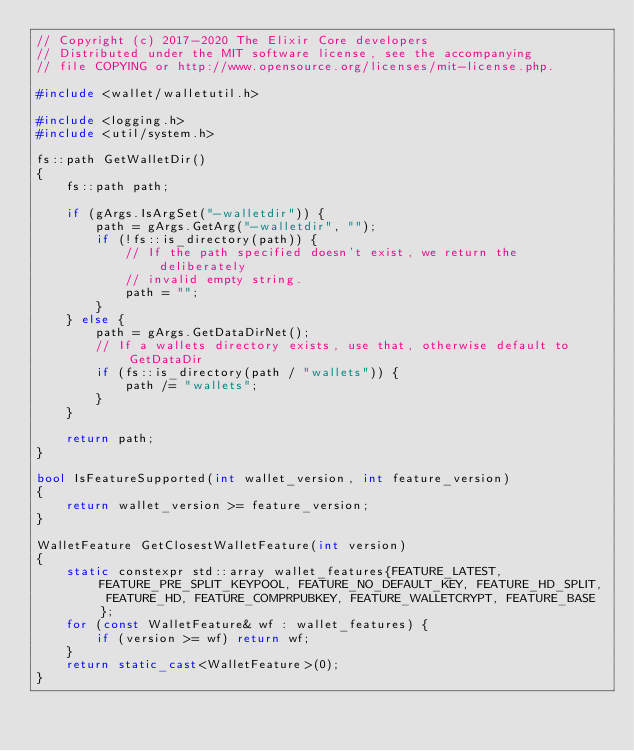<code> <loc_0><loc_0><loc_500><loc_500><_C++_>// Copyright (c) 2017-2020 The Elixir Core developers
// Distributed under the MIT software license, see the accompanying
// file COPYING or http://www.opensource.org/licenses/mit-license.php.

#include <wallet/walletutil.h>

#include <logging.h>
#include <util/system.h>

fs::path GetWalletDir()
{
    fs::path path;

    if (gArgs.IsArgSet("-walletdir")) {
        path = gArgs.GetArg("-walletdir", "");
        if (!fs::is_directory(path)) {
            // If the path specified doesn't exist, we return the deliberately
            // invalid empty string.
            path = "";
        }
    } else {
        path = gArgs.GetDataDirNet();
        // If a wallets directory exists, use that, otherwise default to GetDataDir
        if (fs::is_directory(path / "wallets")) {
            path /= "wallets";
        }
    }

    return path;
}

bool IsFeatureSupported(int wallet_version, int feature_version)
{
    return wallet_version >= feature_version;
}

WalletFeature GetClosestWalletFeature(int version)
{
    static constexpr std::array wallet_features{FEATURE_LATEST, FEATURE_PRE_SPLIT_KEYPOOL, FEATURE_NO_DEFAULT_KEY, FEATURE_HD_SPLIT, FEATURE_HD, FEATURE_COMPRPUBKEY, FEATURE_WALLETCRYPT, FEATURE_BASE};
    for (const WalletFeature& wf : wallet_features) {
        if (version >= wf) return wf;
    }
    return static_cast<WalletFeature>(0);
}
</code> 